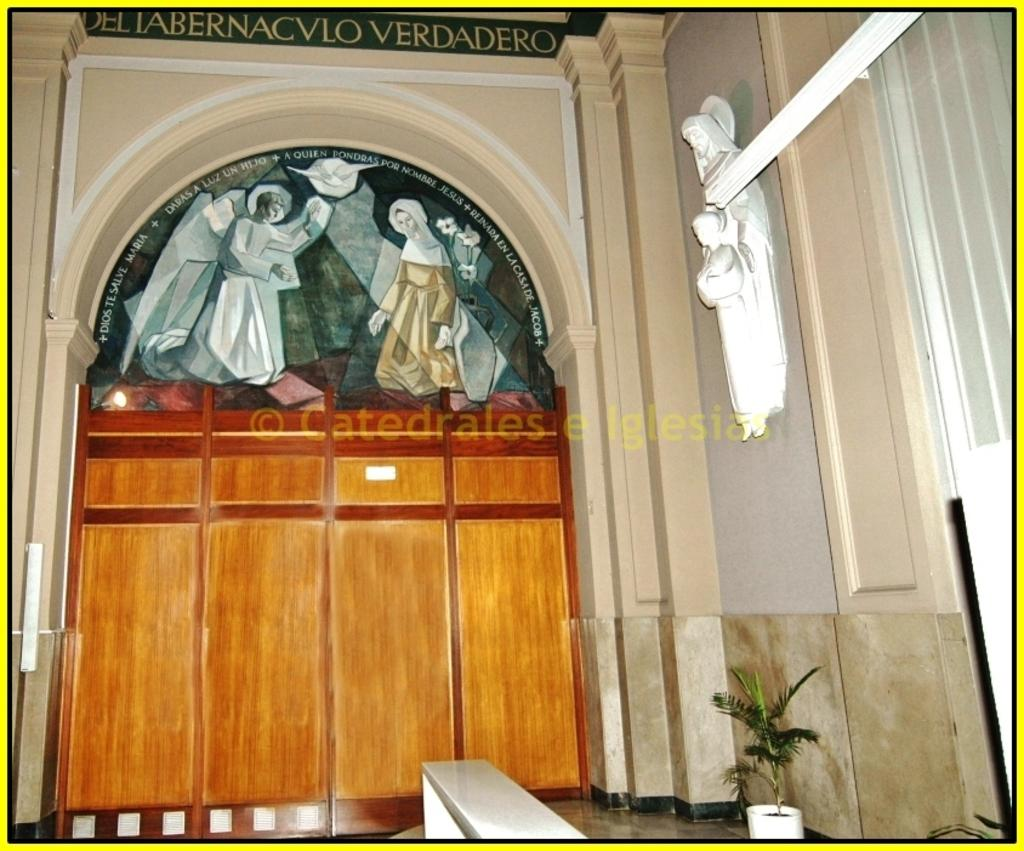What type of structure can be seen in the image? There is an arch in the image. What other objects are present in the image? There are sculptures, pictures of people, and plant pots visible in the image. Can you read any text in the image? Yes, there is text visible in the image. What is the surface that the objects are placed on? The floor is visible in the image. What type of mint can be seen growing near the plant pots in the image? There is no mint present in the image; it only features plant pots. How many volleyballs are visible in the image? There are no volleyballs present in the image. 